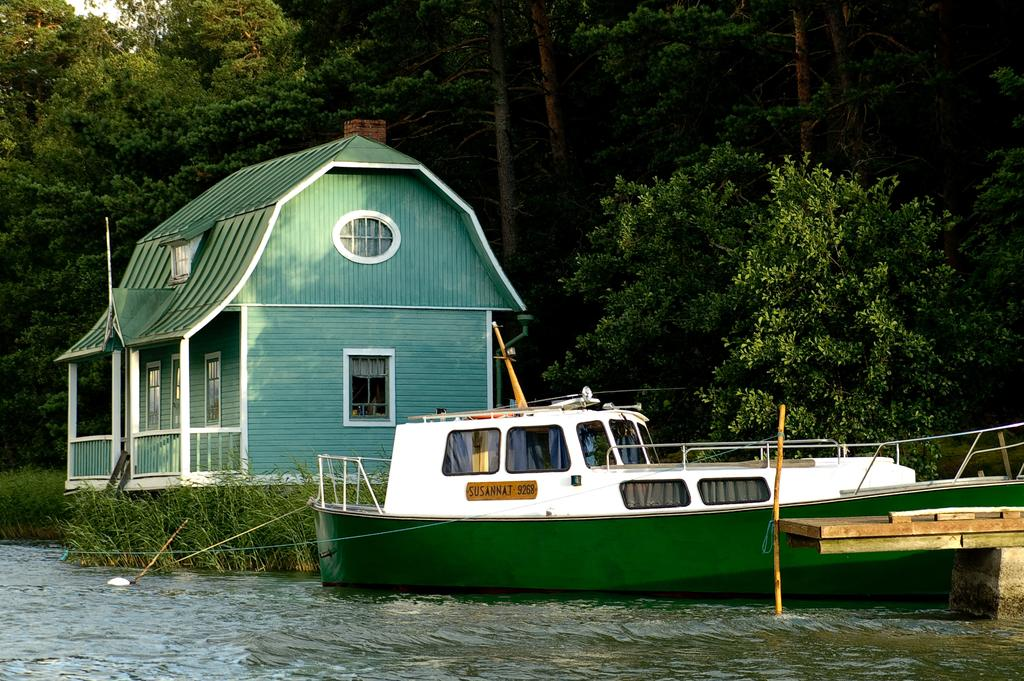What is the main subject of the image? The main subject of the image is a boat. Where is the boat located? The boat is on the water. What can be seen behind the boat? There is a house behind the boat. What type of vegetation is visible in the image? There is grass and trees visible in the image. What part of the natural environment is visible in the image? The sky is visible in the image. What type of guitar can be seen being played by the cow in the image? There is no guitar or cow present in the image; it features a boat on the water with a house in the background. 